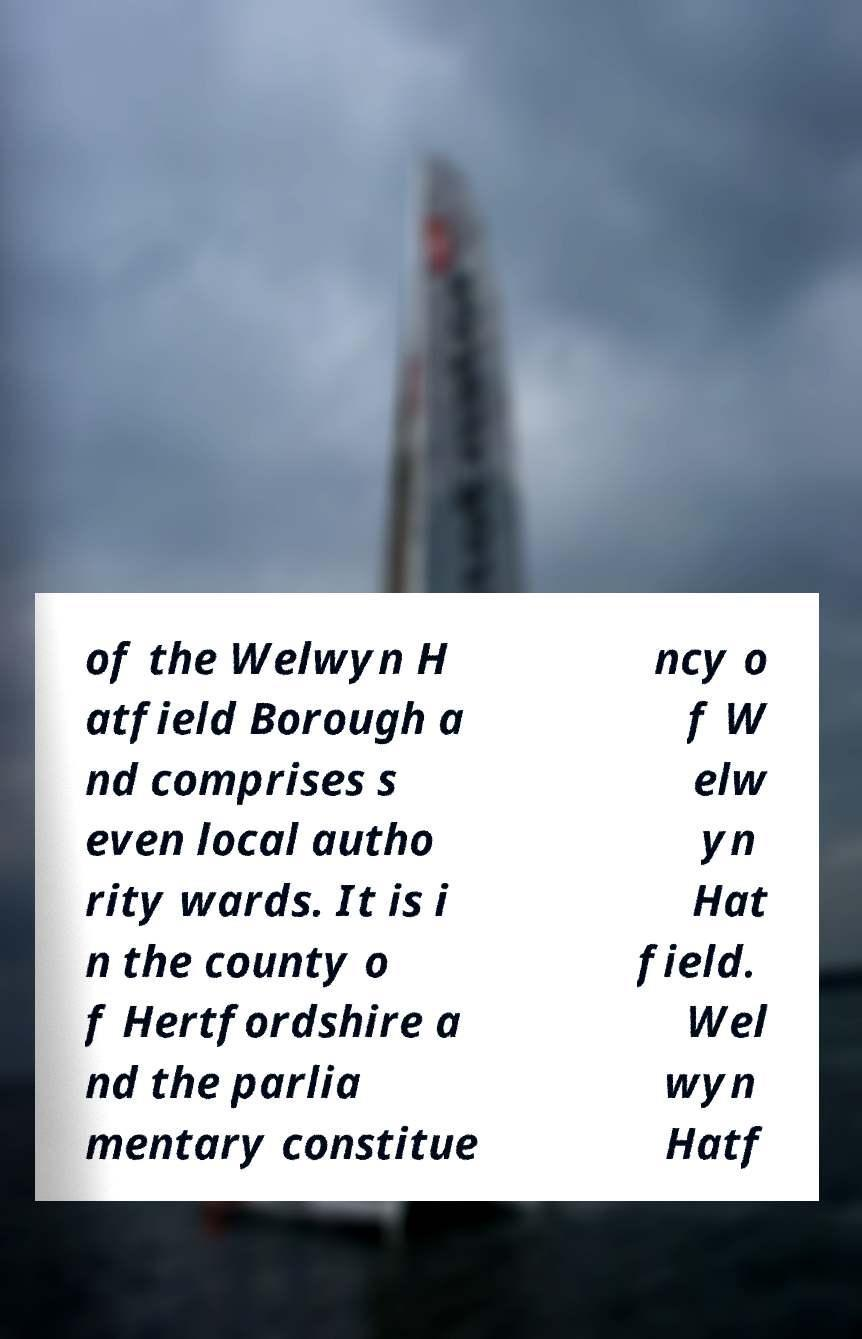What messages or text are displayed in this image? I need them in a readable, typed format. of the Welwyn H atfield Borough a nd comprises s even local autho rity wards. It is i n the county o f Hertfordshire a nd the parlia mentary constitue ncy o f W elw yn Hat field. Wel wyn Hatf 